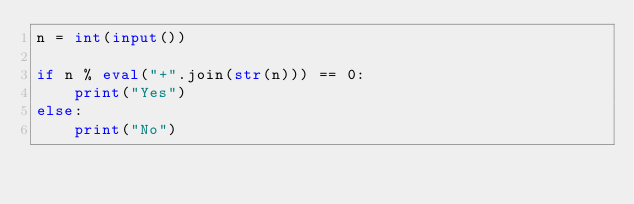Convert code to text. <code><loc_0><loc_0><loc_500><loc_500><_Python_>n = int(input())

if n % eval("+".join(str(n))) == 0:
    print("Yes")
else:
    print("No")
</code> 